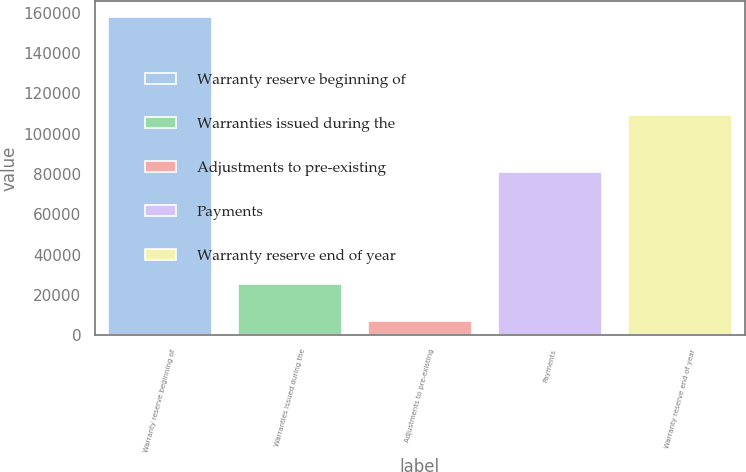Convert chart to OTSL. <chart><loc_0><loc_0><loc_500><loc_500><bar_chart><fcel>Warranty reserve beginning of<fcel>Warranties issued during the<fcel>Adjustments to pre-existing<fcel>Payments<fcel>Warranty reserve end of year<nl><fcel>157896<fcel>25134<fcel>7091<fcel>80942<fcel>109179<nl></chart> 